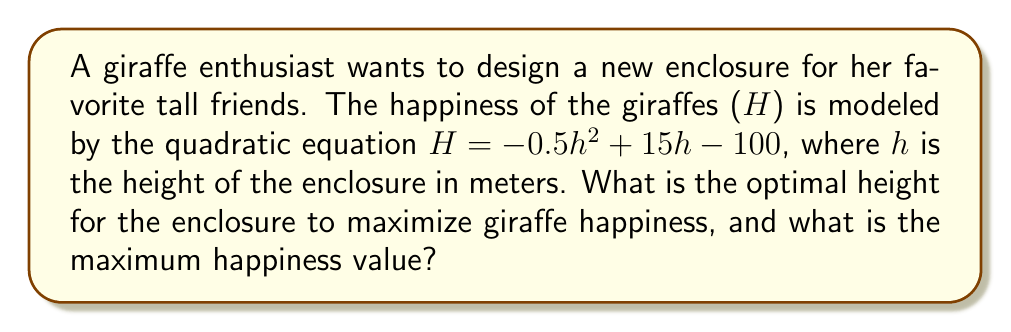Provide a solution to this math problem. To find the optimal height for maximum giraffe happiness, we need to find the vertex of the parabola represented by the quadratic equation $H = -0.5h^2 + 15h - 100$.

Step 1: Identify the coefficients of the quadratic equation.
$a = -0.5$, $b = 15$, $c = -100$

Step 2: Calculate the h-coordinate of the vertex using the formula $h = -\frac{b}{2a}$.
$$h = -\frac{15}{2(-0.5)} = -\frac{15}{-1} = 15$$

Step 3: Calculate the maximum happiness (H) by substituting h = 15 into the original equation.
$$\begin{align*}
H &= -0.5(15)^2 + 15(15) - 100 \\
&= -0.5(225) + 225 - 100 \\
&= -112.5 + 225 - 100 \\
&= 12.5
\end{align*}$$

Therefore, the optimal height for the enclosure is 15 meters, and the maximum happiness value is 12.5 units.
Answer: Optimal height: 15 meters; Maximum happiness: 12.5 units 